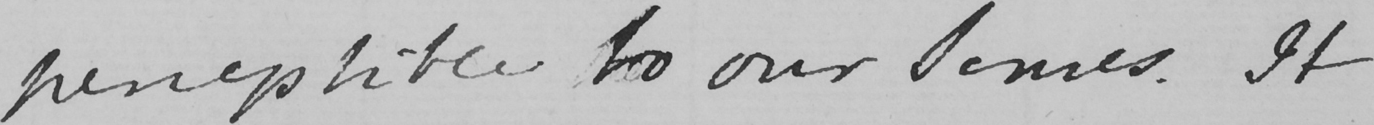Can you tell me what this handwritten text says? perceptible to our selves . It 